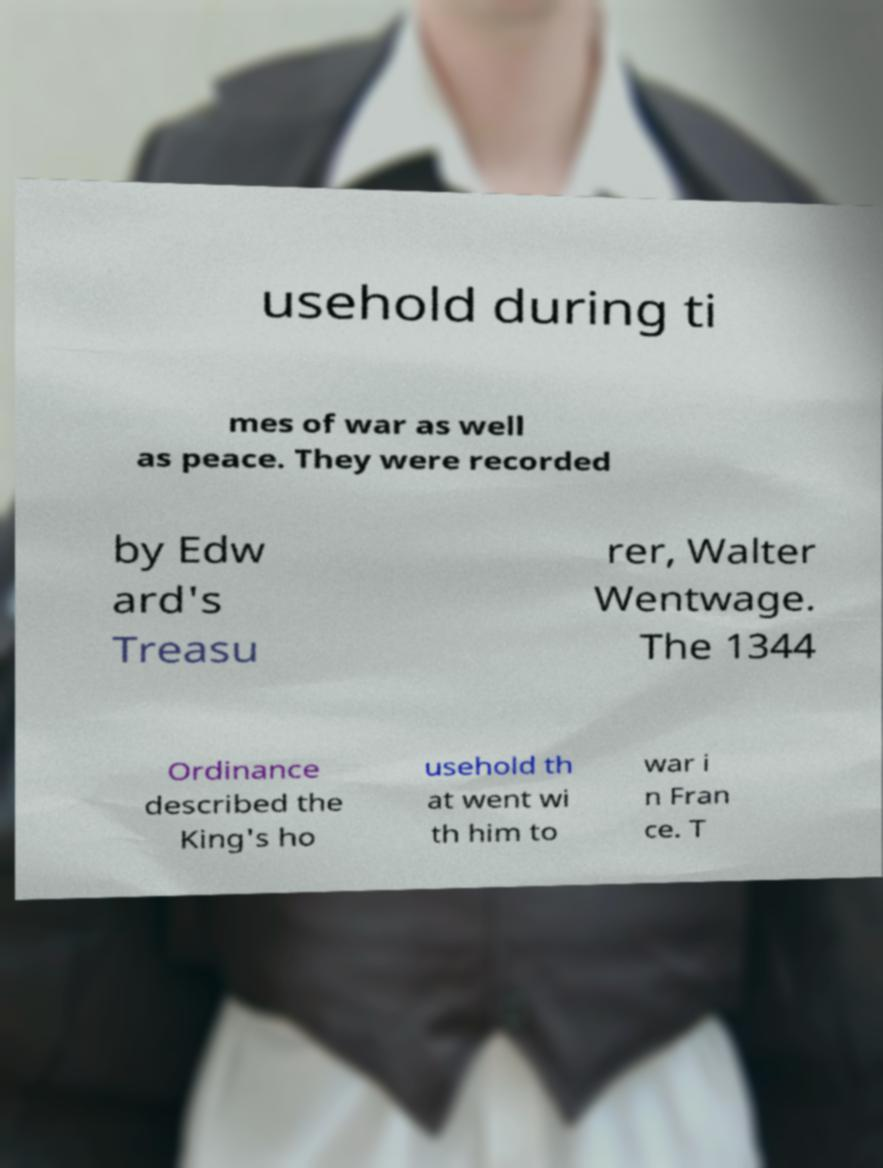For documentation purposes, I need the text within this image transcribed. Could you provide that? usehold during ti mes of war as well as peace. They were recorded by Edw ard's Treasu rer, Walter Wentwage. The 1344 Ordinance described the King's ho usehold th at went wi th him to war i n Fran ce. T 